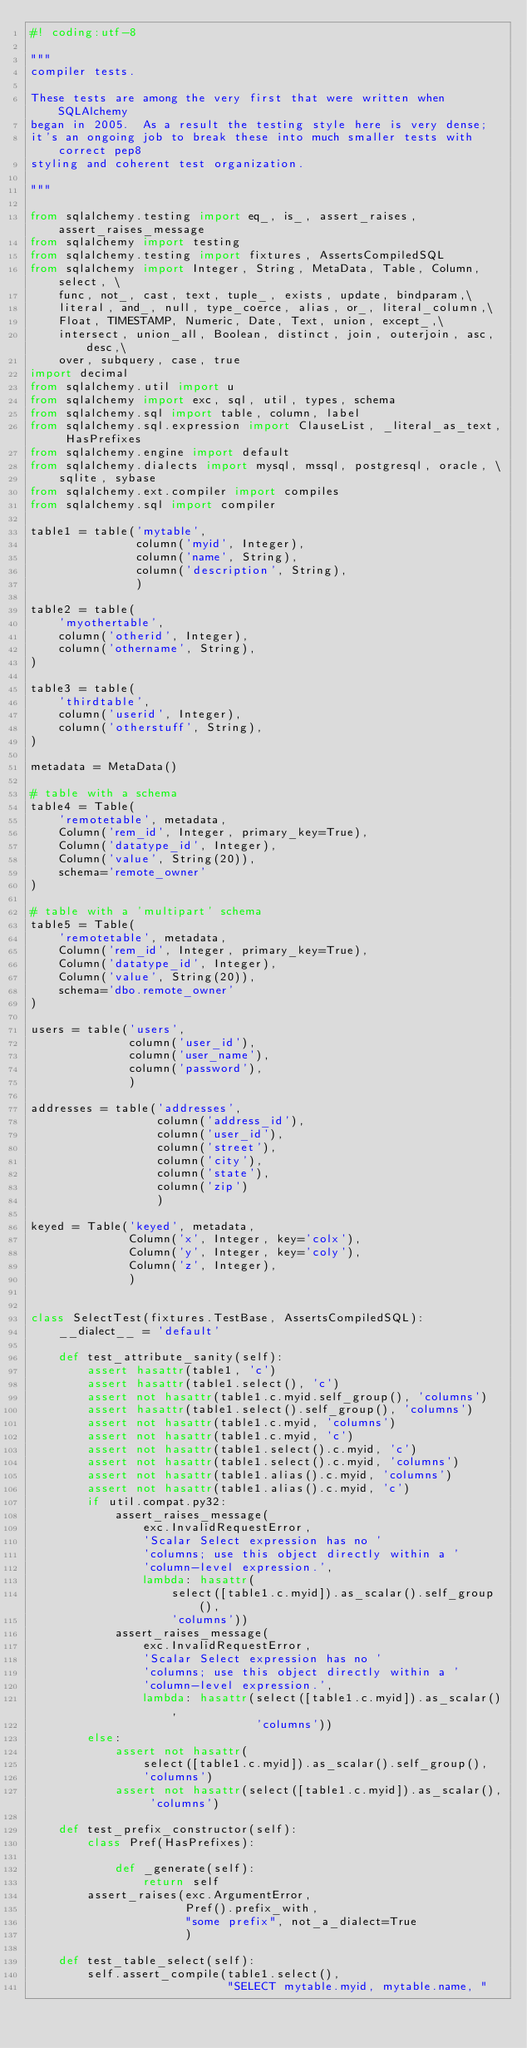Convert code to text. <code><loc_0><loc_0><loc_500><loc_500><_Python_>#! coding:utf-8

"""
compiler tests.

These tests are among the very first that were written when SQLAlchemy
began in 2005.  As a result the testing style here is very dense;
it's an ongoing job to break these into much smaller tests with correct pep8
styling and coherent test organization.

"""

from sqlalchemy.testing import eq_, is_, assert_raises, assert_raises_message
from sqlalchemy import testing
from sqlalchemy.testing import fixtures, AssertsCompiledSQL
from sqlalchemy import Integer, String, MetaData, Table, Column, select, \
    func, not_, cast, text, tuple_, exists, update, bindparam,\
    literal, and_, null, type_coerce, alias, or_, literal_column,\
    Float, TIMESTAMP, Numeric, Date, Text, union, except_,\
    intersect, union_all, Boolean, distinct, join, outerjoin, asc, desc,\
    over, subquery, case, true
import decimal
from sqlalchemy.util import u
from sqlalchemy import exc, sql, util, types, schema
from sqlalchemy.sql import table, column, label
from sqlalchemy.sql.expression import ClauseList, _literal_as_text, HasPrefixes
from sqlalchemy.engine import default
from sqlalchemy.dialects import mysql, mssql, postgresql, oracle, \
    sqlite, sybase
from sqlalchemy.ext.compiler import compiles
from sqlalchemy.sql import compiler

table1 = table('mytable',
               column('myid', Integer),
               column('name', String),
               column('description', String),
               )

table2 = table(
    'myothertable',
    column('otherid', Integer),
    column('othername', String),
)

table3 = table(
    'thirdtable',
    column('userid', Integer),
    column('otherstuff', String),
)

metadata = MetaData()

# table with a schema
table4 = Table(
    'remotetable', metadata,
    Column('rem_id', Integer, primary_key=True),
    Column('datatype_id', Integer),
    Column('value', String(20)),
    schema='remote_owner'
)

# table with a 'multipart' schema
table5 = Table(
    'remotetable', metadata,
    Column('rem_id', Integer, primary_key=True),
    Column('datatype_id', Integer),
    Column('value', String(20)),
    schema='dbo.remote_owner'
)

users = table('users',
              column('user_id'),
              column('user_name'),
              column('password'),
              )

addresses = table('addresses',
                  column('address_id'),
                  column('user_id'),
                  column('street'),
                  column('city'),
                  column('state'),
                  column('zip')
                  )

keyed = Table('keyed', metadata,
              Column('x', Integer, key='colx'),
              Column('y', Integer, key='coly'),
              Column('z', Integer),
              )


class SelectTest(fixtures.TestBase, AssertsCompiledSQL):
    __dialect__ = 'default'

    def test_attribute_sanity(self):
        assert hasattr(table1, 'c')
        assert hasattr(table1.select(), 'c')
        assert not hasattr(table1.c.myid.self_group(), 'columns')
        assert hasattr(table1.select().self_group(), 'columns')
        assert not hasattr(table1.c.myid, 'columns')
        assert not hasattr(table1.c.myid, 'c')
        assert not hasattr(table1.select().c.myid, 'c')
        assert not hasattr(table1.select().c.myid, 'columns')
        assert not hasattr(table1.alias().c.myid, 'columns')
        assert not hasattr(table1.alias().c.myid, 'c')
        if util.compat.py32:
            assert_raises_message(
                exc.InvalidRequestError,
                'Scalar Select expression has no '
                'columns; use this object directly within a '
                'column-level expression.',
                lambda: hasattr(
                    select([table1.c.myid]).as_scalar().self_group(),
                    'columns'))
            assert_raises_message(
                exc.InvalidRequestError,
                'Scalar Select expression has no '
                'columns; use this object directly within a '
                'column-level expression.',
                lambda: hasattr(select([table1.c.myid]).as_scalar(),
                                'columns'))
        else:
            assert not hasattr(
                select([table1.c.myid]).as_scalar().self_group(),
                'columns')
            assert not hasattr(select([table1.c.myid]).as_scalar(), 'columns')

    def test_prefix_constructor(self):
        class Pref(HasPrefixes):

            def _generate(self):
                return self
        assert_raises(exc.ArgumentError,
                      Pref().prefix_with,
                      "some prefix", not_a_dialect=True
                      )

    def test_table_select(self):
        self.assert_compile(table1.select(),
                            "SELECT mytable.myid, mytable.name, "</code> 